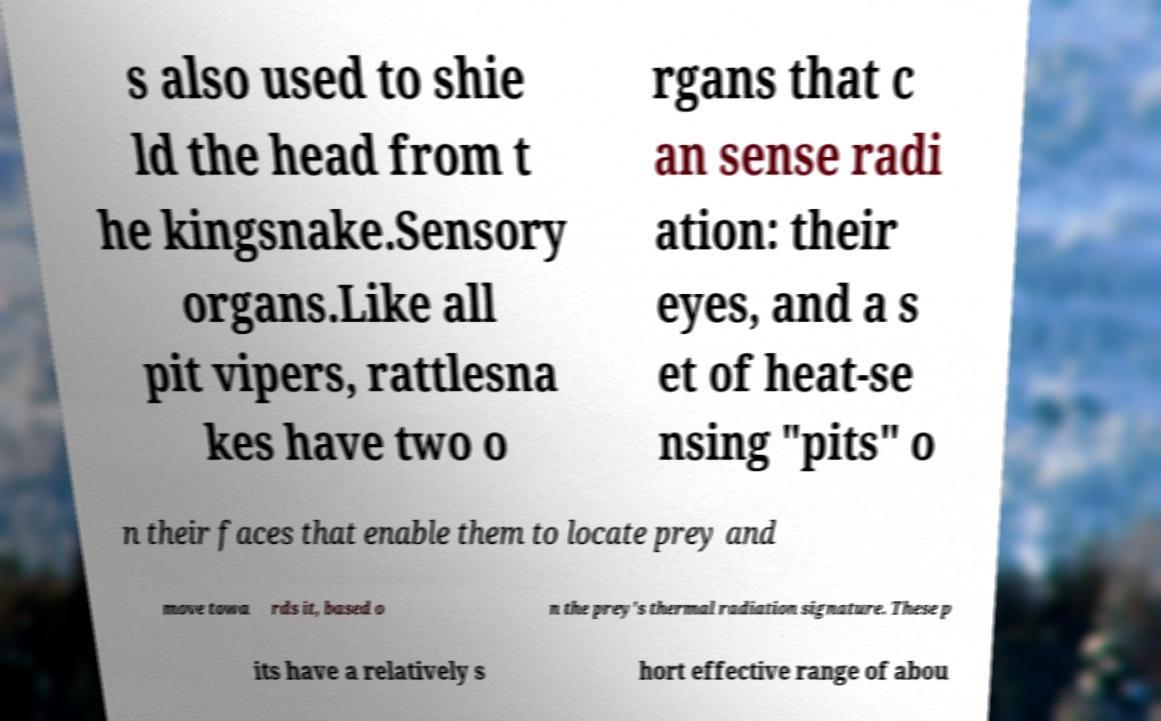Can you read and provide the text displayed in the image?This photo seems to have some interesting text. Can you extract and type it out for me? s also used to shie ld the head from t he kingsnake.Sensory organs.Like all pit vipers, rattlesna kes have two o rgans that c an sense radi ation: their eyes, and a s et of heat-se nsing "pits" o n their faces that enable them to locate prey and move towa rds it, based o n the prey's thermal radiation signature. These p its have a relatively s hort effective range of abou 